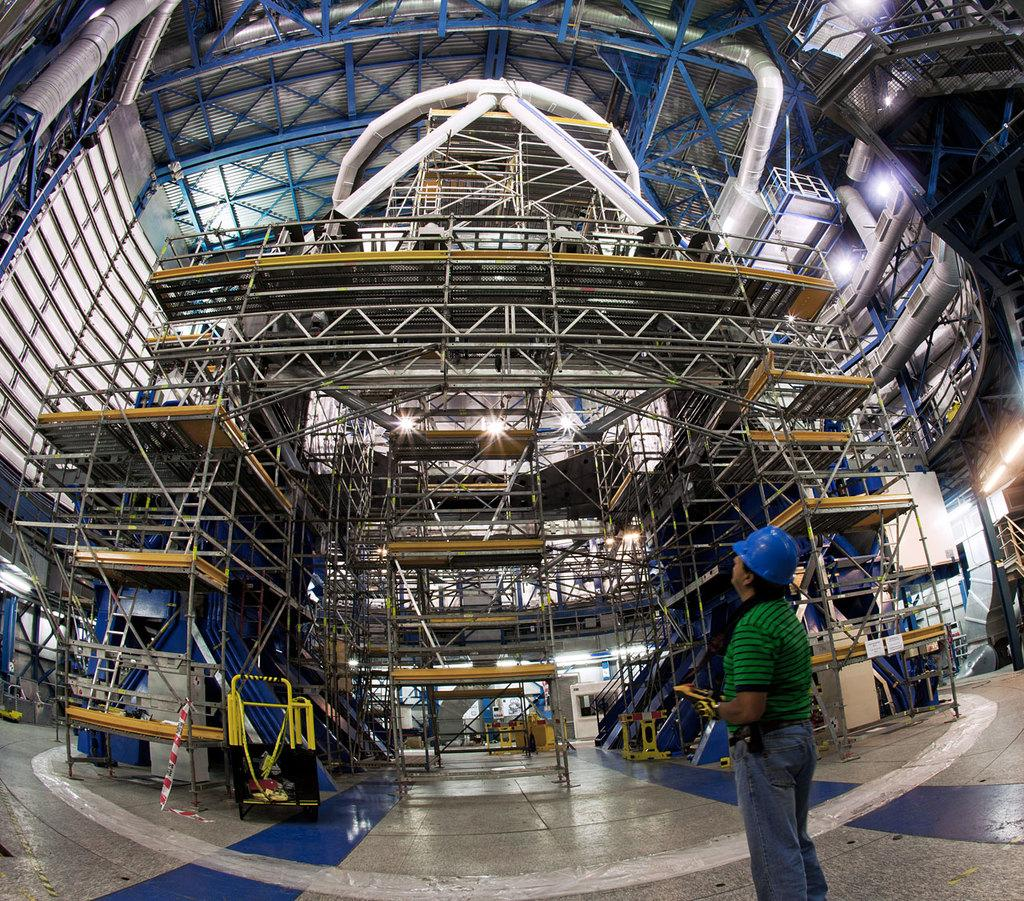What is the primary subject in the image? There is a person standing in the image. Where is the person standing? The person is standing on the floor. What can be seen in front of the person? There is an under-building in front of the person. How many folds are there in the person's clothing in the image? There is no information about the person's clothing in the provided facts, so it is impossible to determine the number of folds. 